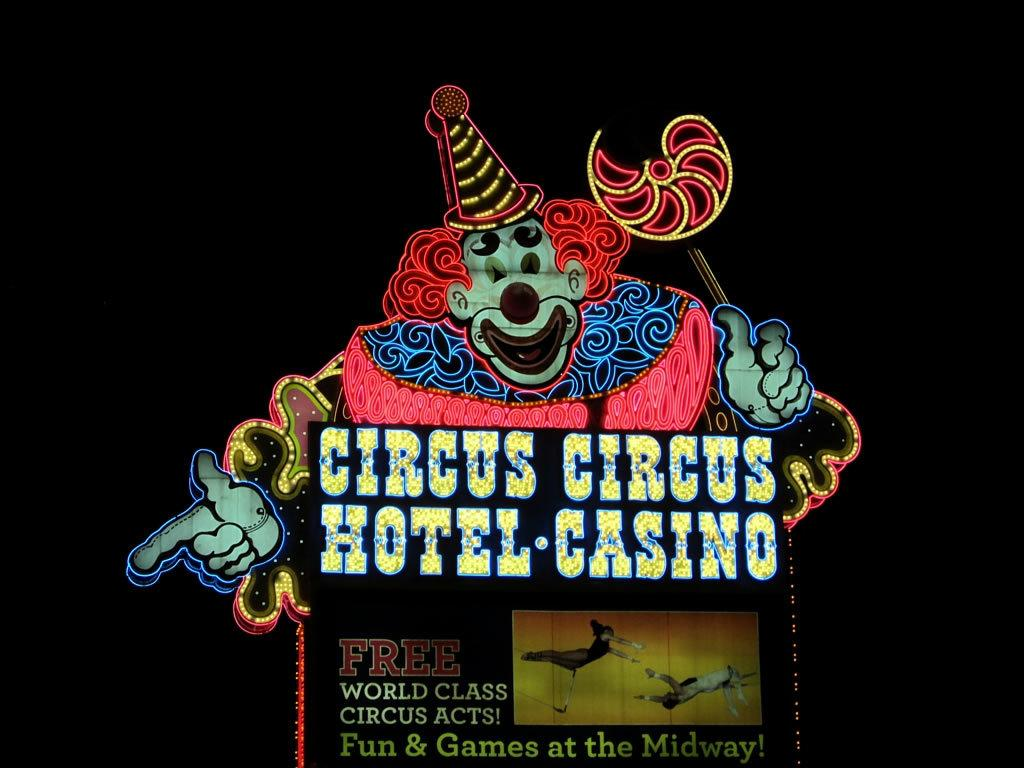<image>
Render a clear and concise summary of the photo. A sign outside Circus Circus Hotel and Casino. 